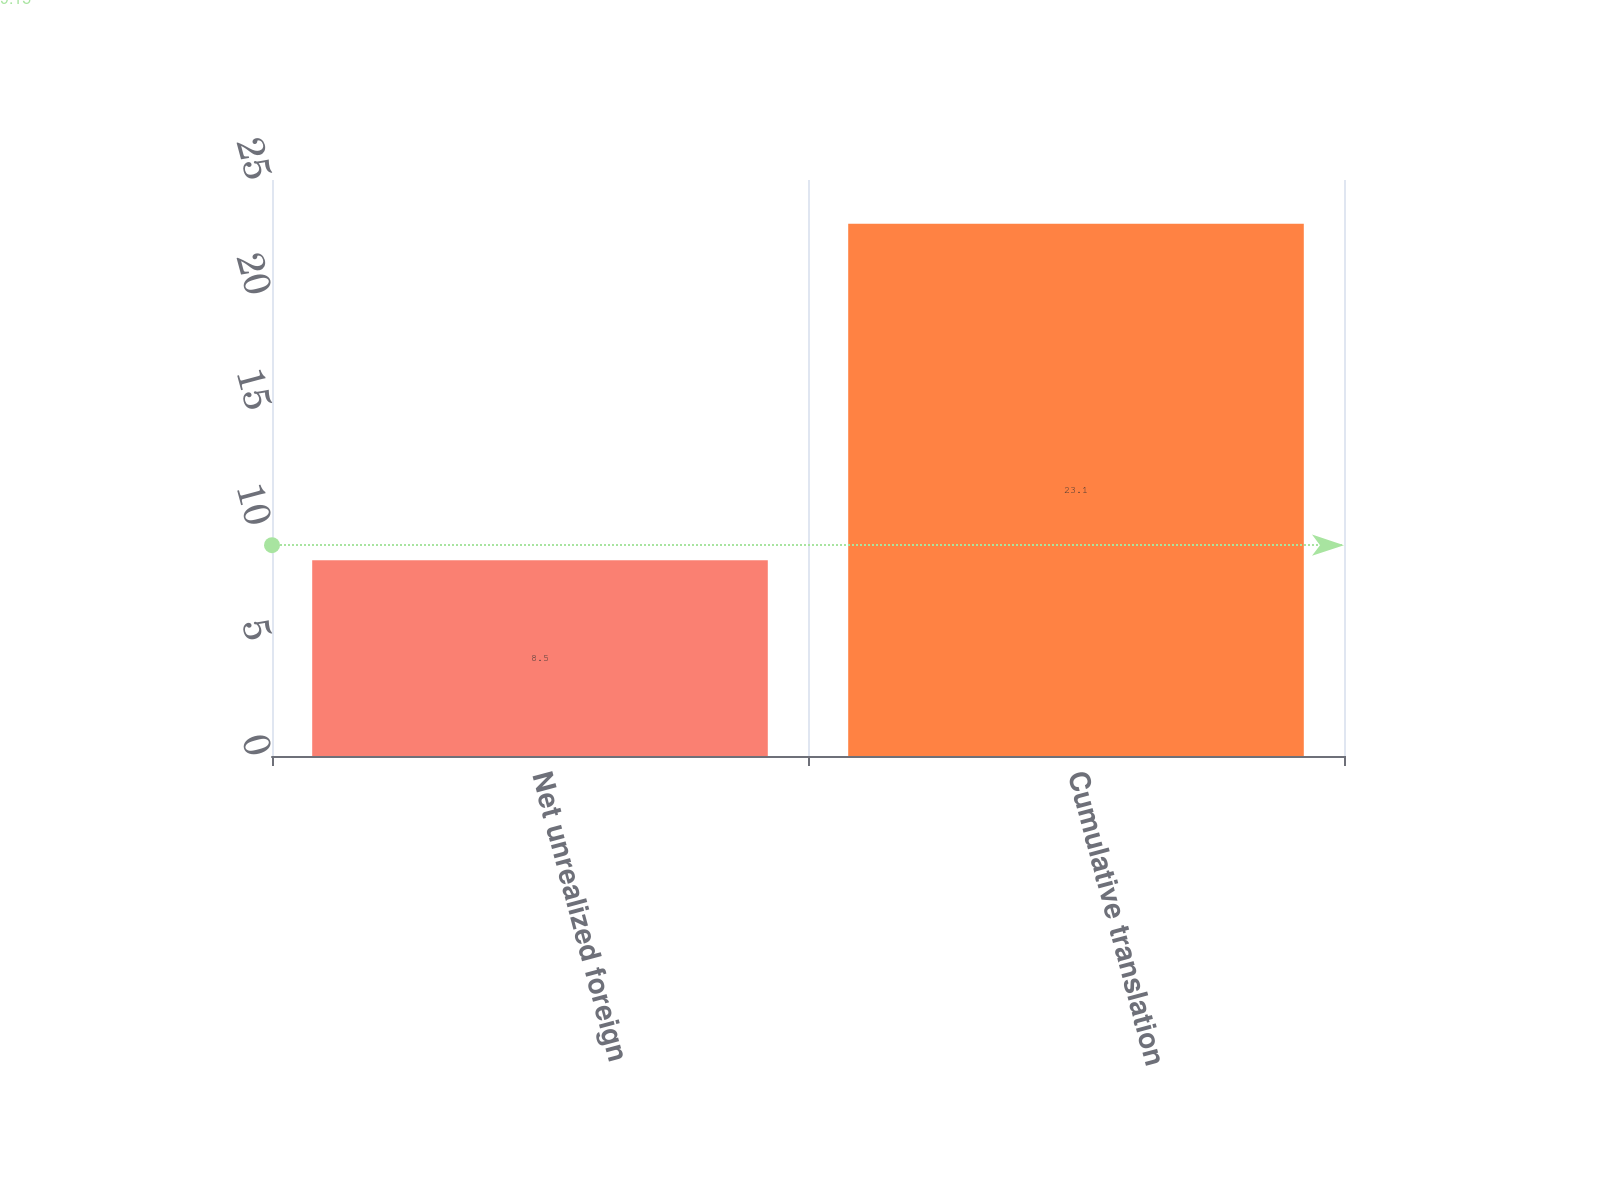Convert chart to OTSL. <chart><loc_0><loc_0><loc_500><loc_500><bar_chart><fcel>Net unrealized foreign<fcel>Cumulative translation<nl><fcel>8.5<fcel>23.1<nl></chart> 